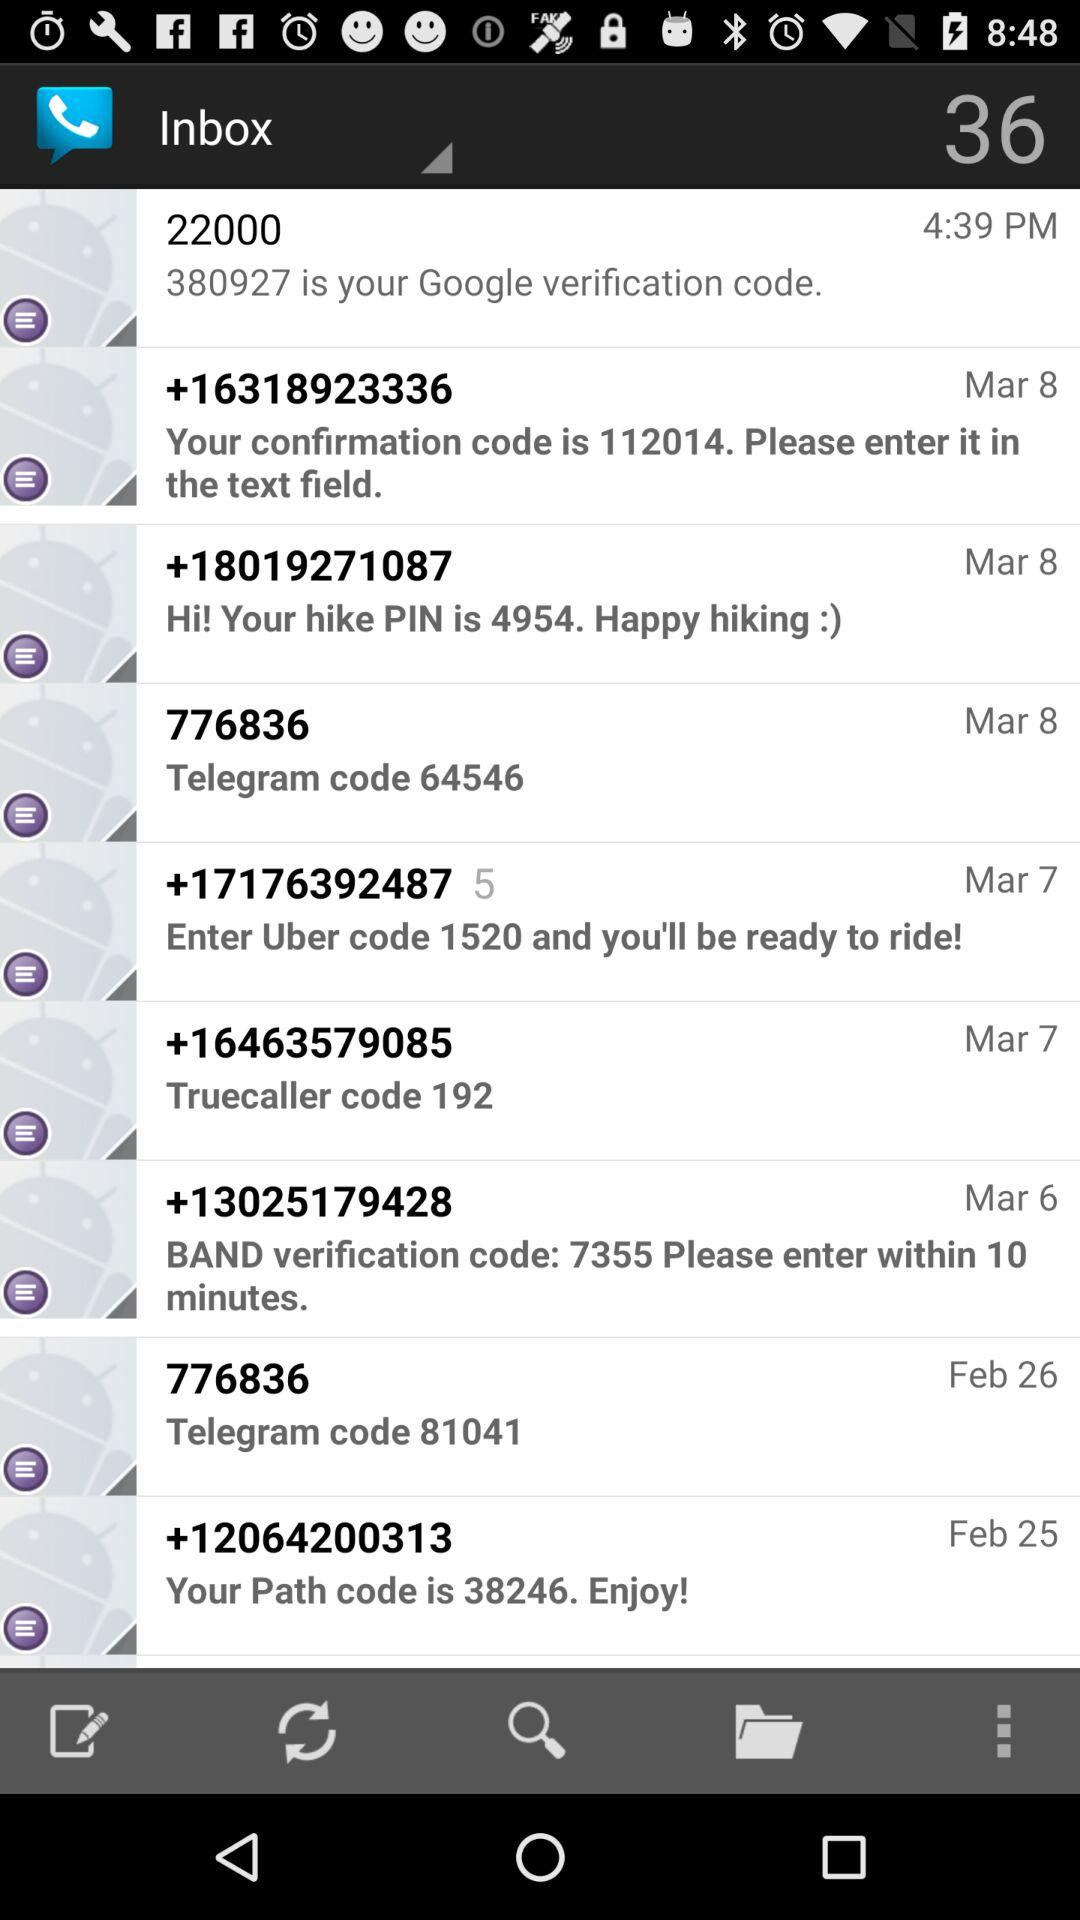For which application is the code 1520? The code 1520 is for "Uber". 